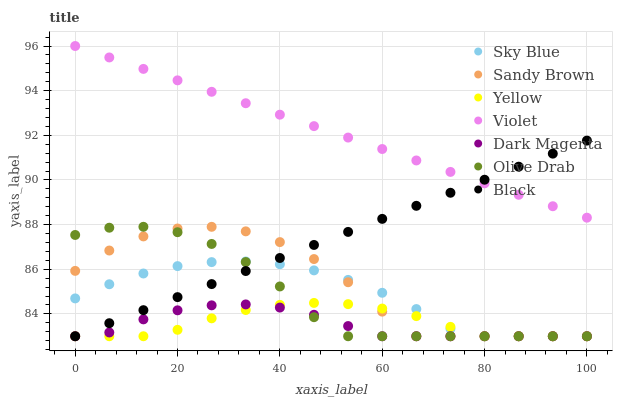Does Dark Magenta have the minimum area under the curve?
Answer yes or no. Yes. Does Violet have the maximum area under the curve?
Answer yes or no. Yes. Does Yellow have the minimum area under the curve?
Answer yes or no. No. Does Yellow have the maximum area under the curve?
Answer yes or no. No. Is Violet the smoothest?
Answer yes or no. Yes. Is Sandy Brown the roughest?
Answer yes or no. Yes. Is Yellow the smoothest?
Answer yes or no. No. Is Yellow the roughest?
Answer yes or no. No. Does Dark Magenta have the lowest value?
Answer yes or no. Yes. Does Violet have the lowest value?
Answer yes or no. No. Does Violet have the highest value?
Answer yes or no. Yes. Does Yellow have the highest value?
Answer yes or no. No. Is Sky Blue less than Violet?
Answer yes or no. Yes. Is Violet greater than Olive Drab?
Answer yes or no. Yes. Does Olive Drab intersect Dark Magenta?
Answer yes or no. Yes. Is Olive Drab less than Dark Magenta?
Answer yes or no. No. Is Olive Drab greater than Dark Magenta?
Answer yes or no. No. Does Sky Blue intersect Violet?
Answer yes or no. No. 